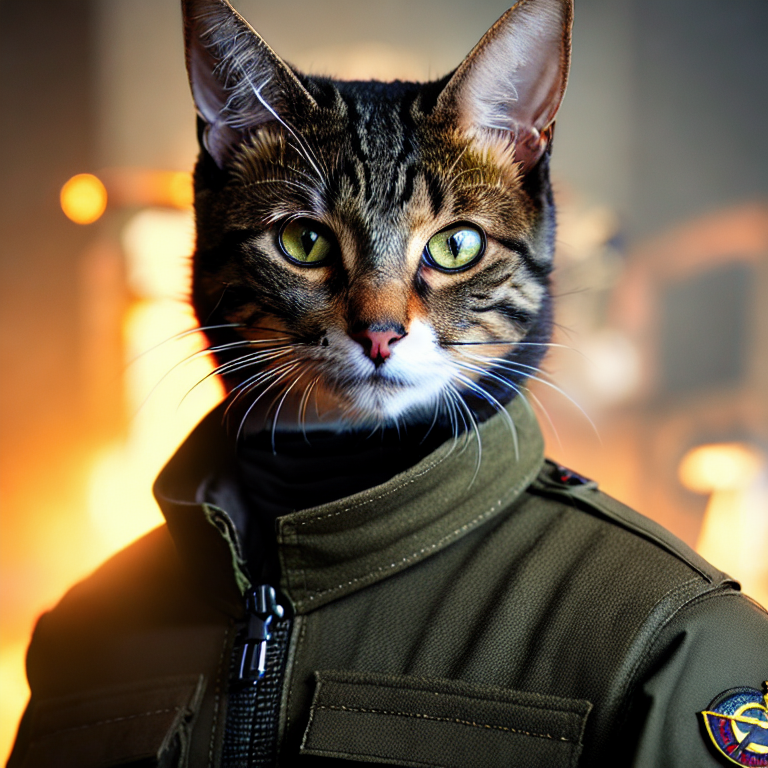Could you explain the significance of the patches seen on the cat's jacket? The patches on the jacket are emblematic, usually used to signify rank, achievements, or affiliations within military units. In this anthropomorphic portrayal, they likely serve to enhance the character’s heroic persona, situating it within a structured, commendable hierarchy. These patches could be imagined elements from fictional military campaigns or majestic battles, adding depth and backstory to the cat’s character as a decorated officer. 